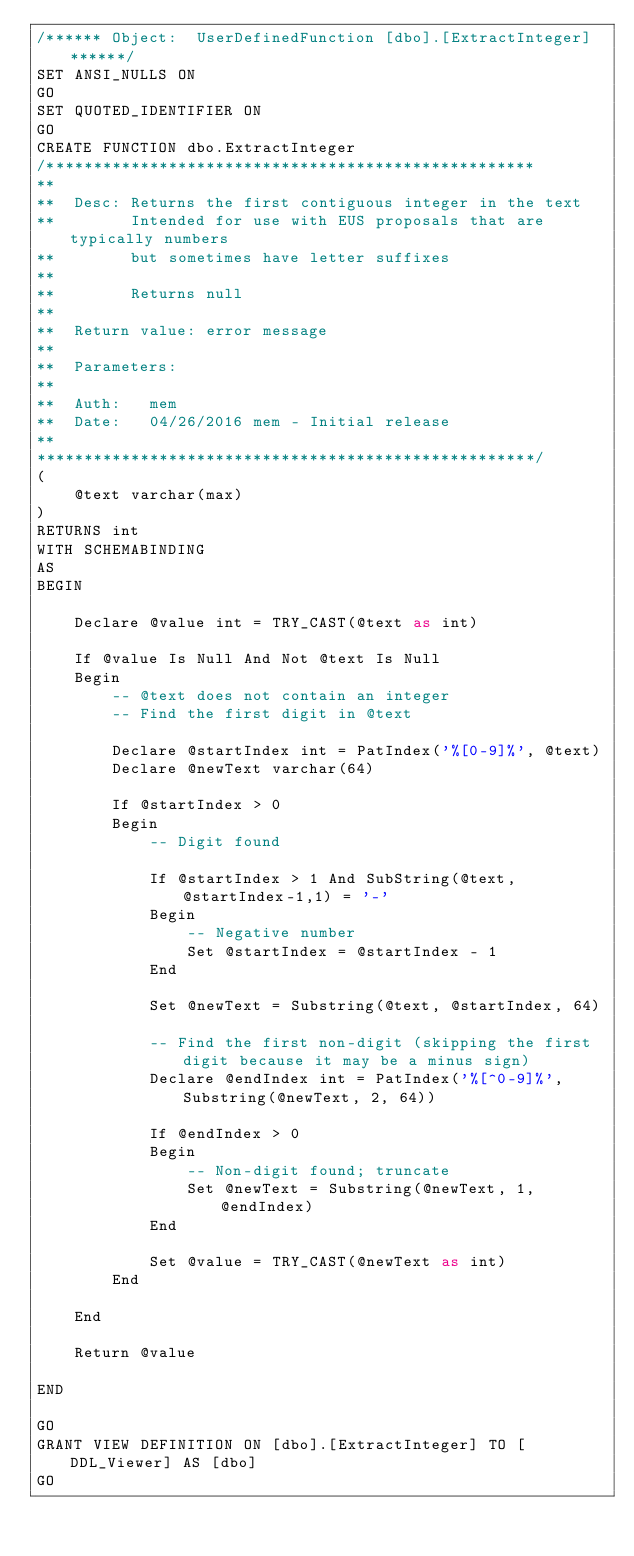Convert code to text. <code><loc_0><loc_0><loc_500><loc_500><_SQL_>/****** Object:  UserDefinedFunction [dbo].[ExtractInteger] ******/
SET ANSI_NULLS ON
GO
SET QUOTED_IDENTIFIER ON
GO
CREATE FUNCTION dbo.ExtractInteger
/****************************************************
**
**	Desc: Returns the first contiguous integer in the text
**		  Intended for use with EUS proposals that are typically numbers
**		  but sometimes have letter suffixes
**
**	      Returns null
**
**	Return value: error message
**
**	Parameters: 
**
**	Auth:	mem
**	Date:	04/26/2016 mem - Initial release
**    
*****************************************************/
(
	@text varchar(max)
)
RETURNS int
WITH SCHEMABINDING
AS
BEGIN

	Declare @value int = TRY_CAST(@text as int)
	
	If @value Is Null And Not @text Is Null
	Begin
		-- @text does not contain an integer
		-- Find the first digit in @text
		
		Declare @startIndex int = PatIndex('%[0-9]%', @text)
		Declare @newText varchar(64)
		
		If @startIndex > 0
		Begin
			-- Digit found
			
			If @startIndex > 1 And SubString(@text, @startIndex-1,1) = '-'			
			Begin
				-- Negative number
				Set @startIndex = @startIndex - 1
			End

			Set @newText = Substring(@text, @startIndex, 64)
			
			-- Find the first non-digit (skipping the first digit because it may be a minus sign)
			Declare @endIndex int = PatIndex('%[^0-9]%', Substring(@newText, 2, 64))
			
			If @endIndex > 0
			Begin
				-- Non-digit found; truncate
				Set @newText = Substring(@newText, 1, @endIndex)
			End
			
			Set @value = TRY_CAST(@newText as int)
		End
		
	End

	Return @value
		
END

GO
GRANT VIEW DEFINITION ON [dbo].[ExtractInteger] TO [DDL_Viewer] AS [dbo]
GO
</code> 